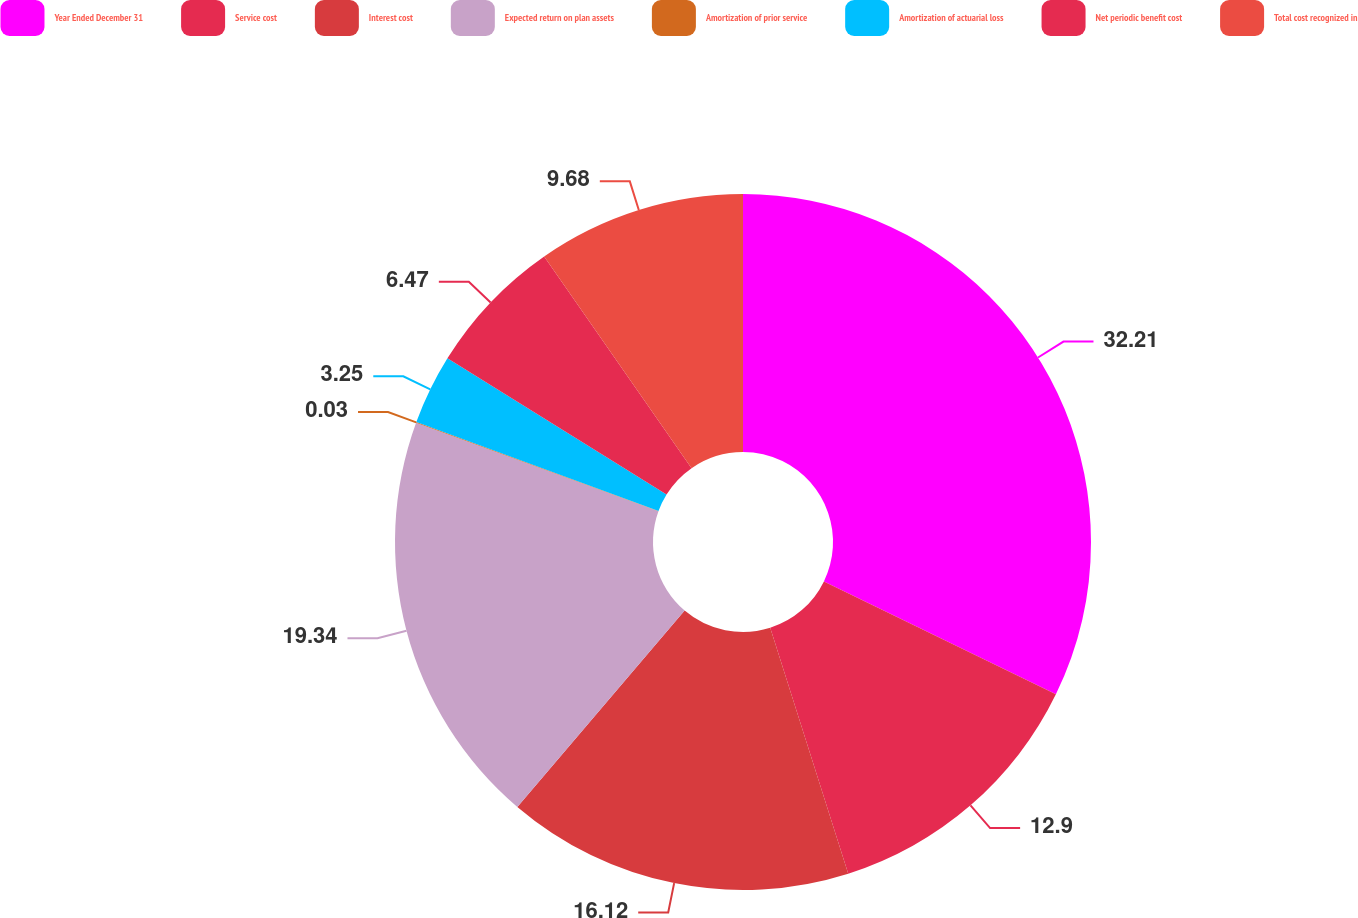<chart> <loc_0><loc_0><loc_500><loc_500><pie_chart><fcel>Year Ended December 31<fcel>Service cost<fcel>Interest cost<fcel>Expected return on plan assets<fcel>Amortization of prior service<fcel>Amortization of actuarial loss<fcel>Net periodic benefit cost<fcel>Total cost recognized in<nl><fcel>32.21%<fcel>12.9%<fcel>16.12%<fcel>19.34%<fcel>0.03%<fcel>3.25%<fcel>6.47%<fcel>9.68%<nl></chart> 